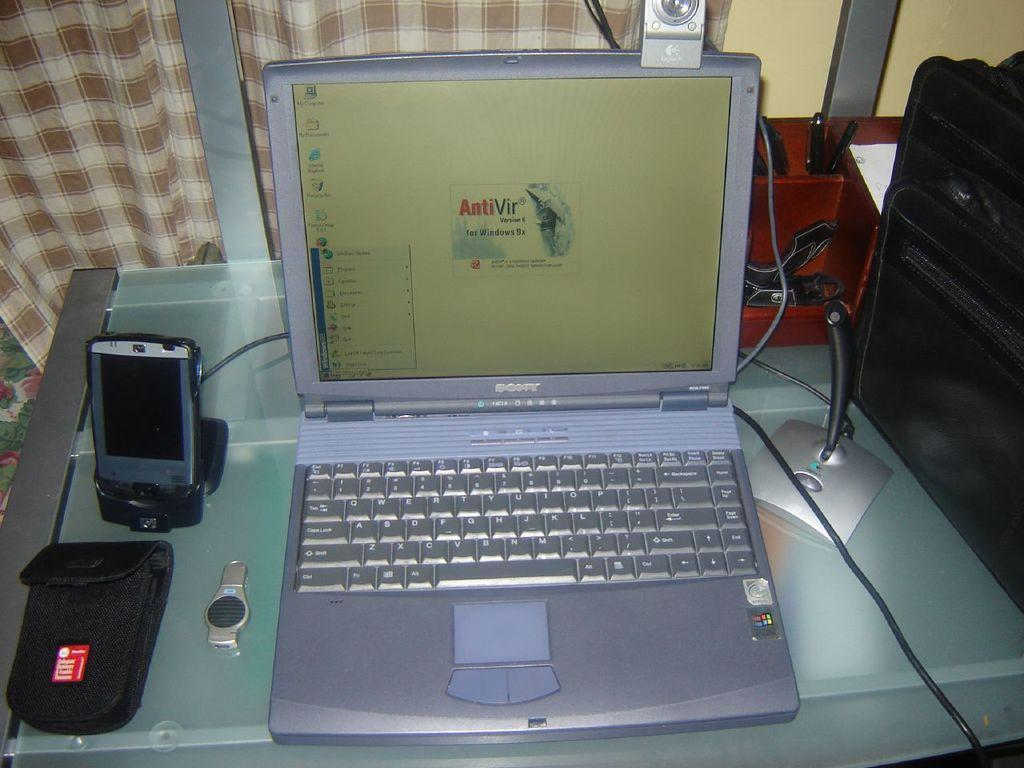<image>
Render a clear and concise summary of the photo. A laptop with AntiVir software pulled up on its screen. 